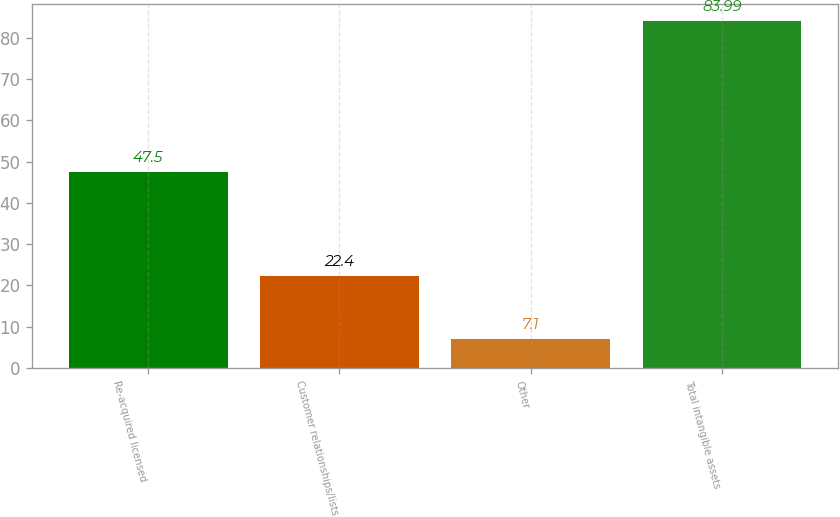<chart> <loc_0><loc_0><loc_500><loc_500><bar_chart><fcel>Re-acquired licensed<fcel>Customer relationships/lists<fcel>Other<fcel>Total intangible assets<nl><fcel>47.5<fcel>22.4<fcel>7.1<fcel>83.99<nl></chart> 